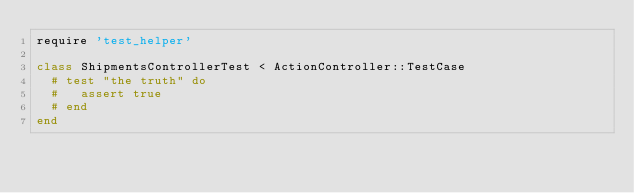Convert code to text. <code><loc_0><loc_0><loc_500><loc_500><_Ruby_>require 'test_helper'

class ShipmentsControllerTest < ActionController::TestCase
  # test "the truth" do
  #   assert true
  # end
end
</code> 